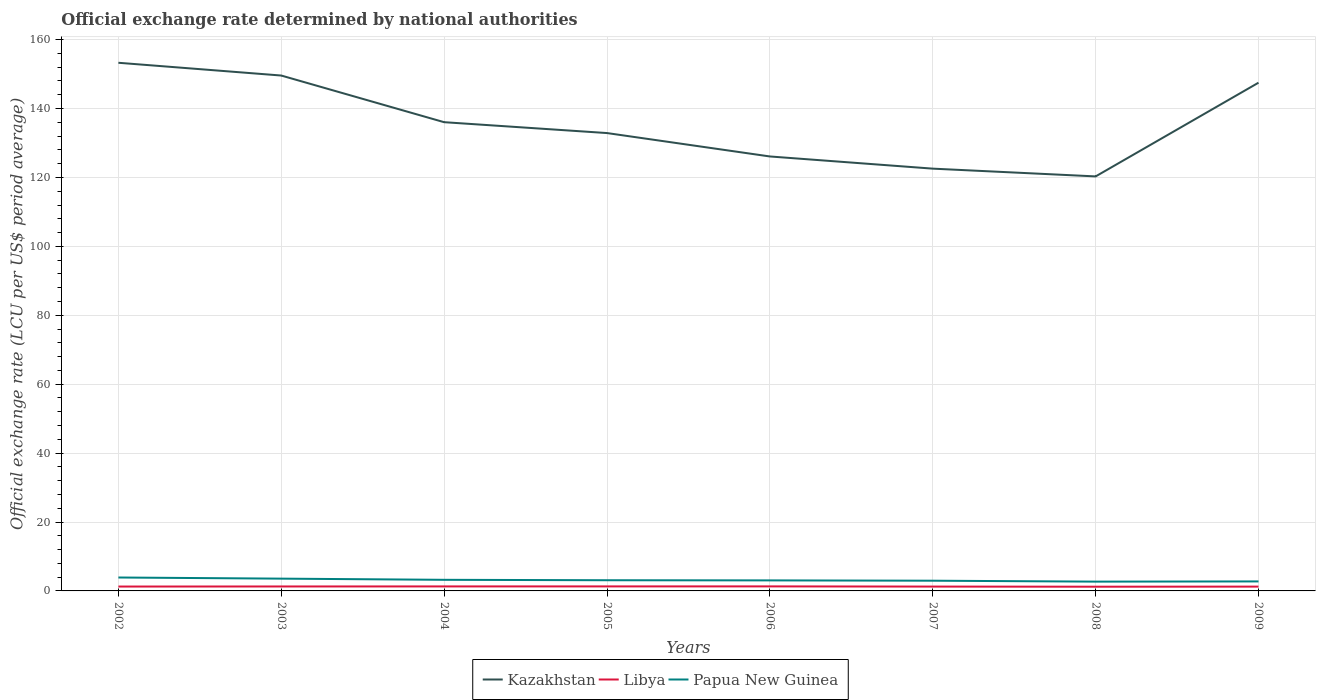How many different coloured lines are there?
Make the answer very short. 3. Is the number of lines equal to the number of legend labels?
Offer a terse response. Yes. Across all years, what is the maximum official exchange rate in Libya?
Provide a succinct answer. 1.22. What is the total official exchange rate in Papua New Guinea in the graph?
Give a very brief answer. 0.86. What is the difference between the highest and the second highest official exchange rate in Libya?
Your answer should be very brief. 0.09. Is the official exchange rate in Papua New Guinea strictly greater than the official exchange rate in Libya over the years?
Keep it short and to the point. No. How many lines are there?
Your answer should be compact. 3. How many years are there in the graph?
Offer a very short reply. 8. Does the graph contain any zero values?
Make the answer very short. No. Does the graph contain grids?
Keep it short and to the point. Yes. Where does the legend appear in the graph?
Your response must be concise. Bottom center. What is the title of the graph?
Make the answer very short. Official exchange rate determined by national authorities. What is the label or title of the Y-axis?
Provide a short and direct response. Official exchange rate (LCU per US$ period average). What is the Official exchange rate (LCU per US$ period average) in Kazakhstan in 2002?
Your response must be concise. 153.28. What is the Official exchange rate (LCU per US$ period average) in Libya in 2002?
Make the answer very short. 1.27. What is the Official exchange rate (LCU per US$ period average) in Papua New Guinea in 2002?
Provide a succinct answer. 3.9. What is the Official exchange rate (LCU per US$ period average) in Kazakhstan in 2003?
Keep it short and to the point. 149.58. What is the Official exchange rate (LCU per US$ period average) of Libya in 2003?
Keep it short and to the point. 1.29. What is the Official exchange rate (LCU per US$ period average) in Papua New Guinea in 2003?
Ensure brevity in your answer.  3.56. What is the Official exchange rate (LCU per US$ period average) of Kazakhstan in 2004?
Your answer should be compact. 136.03. What is the Official exchange rate (LCU per US$ period average) of Libya in 2004?
Ensure brevity in your answer.  1.3. What is the Official exchange rate (LCU per US$ period average) in Papua New Guinea in 2004?
Offer a very short reply. 3.22. What is the Official exchange rate (LCU per US$ period average) in Kazakhstan in 2005?
Keep it short and to the point. 132.88. What is the Official exchange rate (LCU per US$ period average) of Libya in 2005?
Ensure brevity in your answer.  1.31. What is the Official exchange rate (LCU per US$ period average) in Papua New Guinea in 2005?
Keep it short and to the point. 3.1. What is the Official exchange rate (LCU per US$ period average) in Kazakhstan in 2006?
Your answer should be compact. 126.09. What is the Official exchange rate (LCU per US$ period average) of Libya in 2006?
Provide a succinct answer. 1.31. What is the Official exchange rate (LCU per US$ period average) in Papua New Guinea in 2006?
Provide a succinct answer. 3.06. What is the Official exchange rate (LCU per US$ period average) in Kazakhstan in 2007?
Your answer should be compact. 122.55. What is the Official exchange rate (LCU per US$ period average) of Libya in 2007?
Give a very brief answer. 1.26. What is the Official exchange rate (LCU per US$ period average) in Papua New Guinea in 2007?
Make the answer very short. 2.97. What is the Official exchange rate (LCU per US$ period average) in Kazakhstan in 2008?
Your answer should be compact. 120.3. What is the Official exchange rate (LCU per US$ period average) in Libya in 2008?
Ensure brevity in your answer.  1.22. What is the Official exchange rate (LCU per US$ period average) of Papua New Guinea in 2008?
Provide a short and direct response. 2.7. What is the Official exchange rate (LCU per US$ period average) of Kazakhstan in 2009?
Offer a terse response. 147.5. What is the Official exchange rate (LCU per US$ period average) in Libya in 2009?
Offer a very short reply. 1.25. What is the Official exchange rate (LCU per US$ period average) of Papua New Guinea in 2009?
Your answer should be compact. 2.76. Across all years, what is the maximum Official exchange rate (LCU per US$ period average) of Kazakhstan?
Make the answer very short. 153.28. Across all years, what is the maximum Official exchange rate (LCU per US$ period average) of Libya?
Keep it short and to the point. 1.31. Across all years, what is the maximum Official exchange rate (LCU per US$ period average) in Papua New Guinea?
Give a very brief answer. 3.9. Across all years, what is the minimum Official exchange rate (LCU per US$ period average) of Kazakhstan?
Keep it short and to the point. 120.3. Across all years, what is the minimum Official exchange rate (LCU per US$ period average) in Libya?
Your answer should be very brief. 1.22. Across all years, what is the minimum Official exchange rate (LCU per US$ period average) of Papua New Guinea?
Your answer should be compact. 2.7. What is the total Official exchange rate (LCU per US$ period average) of Kazakhstan in the graph?
Give a very brief answer. 1088.21. What is the total Official exchange rate (LCU per US$ period average) in Libya in the graph?
Provide a succinct answer. 10.23. What is the total Official exchange rate (LCU per US$ period average) of Papua New Guinea in the graph?
Keep it short and to the point. 25.26. What is the difference between the Official exchange rate (LCU per US$ period average) in Kazakhstan in 2002 and that in 2003?
Your answer should be very brief. 3.7. What is the difference between the Official exchange rate (LCU per US$ period average) in Libya in 2002 and that in 2003?
Your response must be concise. -0.02. What is the difference between the Official exchange rate (LCU per US$ period average) in Papua New Guinea in 2002 and that in 2003?
Your response must be concise. 0.33. What is the difference between the Official exchange rate (LCU per US$ period average) in Kazakhstan in 2002 and that in 2004?
Ensure brevity in your answer.  17.24. What is the difference between the Official exchange rate (LCU per US$ period average) of Libya in 2002 and that in 2004?
Offer a very short reply. -0.03. What is the difference between the Official exchange rate (LCU per US$ period average) in Papua New Guinea in 2002 and that in 2004?
Provide a short and direct response. 0.67. What is the difference between the Official exchange rate (LCU per US$ period average) in Kazakhstan in 2002 and that in 2005?
Your response must be concise. 20.4. What is the difference between the Official exchange rate (LCU per US$ period average) in Libya in 2002 and that in 2005?
Your response must be concise. -0.04. What is the difference between the Official exchange rate (LCU per US$ period average) of Papua New Guinea in 2002 and that in 2005?
Your answer should be very brief. 0.79. What is the difference between the Official exchange rate (LCU per US$ period average) in Kazakhstan in 2002 and that in 2006?
Your answer should be compact. 27.19. What is the difference between the Official exchange rate (LCU per US$ period average) of Libya in 2002 and that in 2006?
Your response must be concise. -0.04. What is the difference between the Official exchange rate (LCU per US$ period average) in Papua New Guinea in 2002 and that in 2006?
Your answer should be compact. 0.84. What is the difference between the Official exchange rate (LCU per US$ period average) of Kazakhstan in 2002 and that in 2007?
Your response must be concise. 30.73. What is the difference between the Official exchange rate (LCU per US$ period average) in Libya in 2002 and that in 2007?
Ensure brevity in your answer.  0.01. What is the difference between the Official exchange rate (LCU per US$ period average) in Papua New Guinea in 2002 and that in 2007?
Provide a succinct answer. 0.93. What is the difference between the Official exchange rate (LCU per US$ period average) in Kazakhstan in 2002 and that in 2008?
Your response must be concise. 32.98. What is the difference between the Official exchange rate (LCU per US$ period average) in Libya in 2002 and that in 2008?
Give a very brief answer. 0.05. What is the difference between the Official exchange rate (LCU per US$ period average) in Papua New Guinea in 2002 and that in 2008?
Offer a terse response. 1.2. What is the difference between the Official exchange rate (LCU per US$ period average) of Kazakhstan in 2002 and that in 2009?
Provide a short and direct response. 5.78. What is the difference between the Official exchange rate (LCU per US$ period average) in Libya in 2002 and that in 2009?
Offer a terse response. 0.02. What is the difference between the Official exchange rate (LCU per US$ period average) of Papua New Guinea in 2002 and that in 2009?
Ensure brevity in your answer.  1.14. What is the difference between the Official exchange rate (LCU per US$ period average) in Kazakhstan in 2003 and that in 2004?
Provide a short and direct response. 13.54. What is the difference between the Official exchange rate (LCU per US$ period average) of Libya in 2003 and that in 2004?
Give a very brief answer. -0.01. What is the difference between the Official exchange rate (LCU per US$ period average) of Papua New Guinea in 2003 and that in 2004?
Offer a very short reply. 0.34. What is the difference between the Official exchange rate (LCU per US$ period average) in Kazakhstan in 2003 and that in 2005?
Make the answer very short. 16.7. What is the difference between the Official exchange rate (LCU per US$ period average) in Libya in 2003 and that in 2005?
Provide a succinct answer. -0.02. What is the difference between the Official exchange rate (LCU per US$ period average) of Papua New Guinea in 2003 and that in 2005?
Provide a succinct answer. 0.46. What is the difference between the Official exchange rate (LCU per US$ period average) of Kazakhstan in 2003 and that in 2006?
Ensure brevity in your answer.  23.49. What is the difference between the Official exchange rate (LCU per US$ period average) in Libya in 2003 and that in 2006?
Offer a very short reply. -0.02. What is the difference between the Official exchange rate (LCU per US$ period average) of Papua New Guinea in 2003 and that in 2006?
Your response must be concise. 0.51. What is the difference between the Official exchange rate (LCU per US$ period average) in Kazakhstan in 2003 and that in 2007?
Your response must be concise. 27.02. What is the difference between the Official exchange rate (LCU per US$ period average) of Libya in 2003 and that in 2007?
Give a very brief answer. 0.03. What is the difference between the Official exchange rate (LCU per US$ period average) in Papua New Guinea in 2003 and that in 2007?
Provide a short and direct response. 0.6. What is the difference between the Official exchange rate (LCU per US$ period average) in Kazakhstan in 2003 and that in 2008?
Offer a terse response. 29.28. What is the difference between the Official exchange rate (LCU per US$ period average) of Libya in 2003 and that in 2008?
Offer a very short reply. 0.07. What is the difference between the Official exchange rate (LCU per US$ period average) of Papua New Guinea in 2003 and that in 2008?
Ensure brevity in your answer.  0.86. What is the difference between the Official exchange rate (LCU per US$ period average) in Kazakhstan in 2003 and that in 2009?
Make the answer very short. 2.08. What is the difference between the Official exchange rate (LCU per US$ period average) of Libya in 2003 and that in 2009?
Provide a short and direct response. 0.04. What is the difference between the Official exchange rate (LCU per US$ period average) in Papua New Guinea in 2003 and that in 2009?
Ensure brevity in your answer.  0.81. What is the difference between the Official exchange rate (LCU per US$ period average) in Kazakhstan in 2004 and that in 2005?
Provide a succinct answer. 3.15. What is the difference between the Official exchange rate (LCU per US$ period average) of Libya in 2004 and that in 2005?
Offer a very short reply. -0. What is the difference between the Official exchange rate (LCU per US$ period average) in Papua New Guinea in 2004 and that in 2005?
Offer a terse response. 0.12. What is the difference between the Official exchange rate (LCU per US$ period average) of Kazakhstan in 2004 and that in 2006?
Your answer should be very brief. 9.95. What is the difference between the Official exchange rate (LCU per US$ period average) in Libya in 2004 and that in 2006?
Give a very brief answer. -0.01. What is the difference between the Official exchange rate (LCU per US$ period average) in Papua New Guinea in 2004 and that in 2006?
Make the answer very short. 0.17. What is the difference between the Official exchange rate (LCU per US$ period average) of Kazakhstan in 2004 and that in 2007?
Your response must be concise. 13.48. What is the difference between the Official exchange rate (LCU per US$ period average) in Libya in 2004 and that in 2007?
Offer a very short reply. 0.04. What is the difference between the Official exchange rate (LCU per US$ period average) of Papua New Guinea in 2004 and that in 2007?
Provide a succinct answer. 0.26. What is the difference between the Official exchange rate (LCU per US$ period average) of Kazakhstan in 2004 and that in 2008?
Make the answer very short. 15.74. What is the difference between the Official exchange rate (LCU per US$ period average) in Libya in 2004 and that in 2008?
Offer a terse response. 0.08. What is the difference between the Official exchange rate (LCU per US$ period average) in Papua New Guinea in 2004 and that in 2008?
Keep it short and to the point. 0.52. What is the difference between the Official exchange rate (LCU per US$ period average) of Kazakhstan in 2004 and that in 2009?
Offer a terse response. -11.46. What is the difference between the Official exchange rate (LCU per US$ period average) of Libya in 2004 and that in 2009?
Ensure brevity in your answer.  0.05. What is the difference between the Official exchange rate (LCU per US$ period average) in Papua New Guinea in 2004 and that in 2009?
Provide a succinct answer. 0.47. What is the difference between the Official exchange rate (LCU per US$ period average) in Kazakhstan in 2005 and that in 2006?
Your response must be concise. 6.79. What is the difference between the Official exchange rate (LCU per US$ period average) in Libya in 2005 and that in 2006?
Make the answer very short. -0.01. What is the difference between the Official exchange rate (LCU per US$ period average) of Papua New Guinea in 2005 and that in 2006?
Offer a very short reply. 0.05. What is the difference between the Official exchange rate (LCU per US$ period average) in Kazakhstan in 2005 and that in 2007?
Offer a very short reply. 10.33. What is the difference between the Official exchange rate (LCU per US$ period average) in Libya in 2005 and that in 2007?
Your answer should be very brief. 0.05. What is the difference between the Official exchange rate (LCU per US$ period average) in Papua New Guinea in 2005 and that in 2007?
Your answer should be very brief. 0.14. What is the difference between the Official exchange rate (LCU per US$ period average) of Kazakhstan in 2005 and that in 2008?
Provide a succinct answer. 12.58. What is the difference between the Official exchange rate (LCU per US$ period average) in Libya in 2005 and that in 2008?
Give a very brief answer. 0.08. What is the difference between the Official exchange rate (LCU per US$ period average) of Papua New Guinea in 2005 and that in 2008?
Your response must be concise. 0.4. What is the difference between the Official exchange rate (LCU per US$ period average) in Kazakhstan in 2005 and that in 2009?
Offer a very short reply. -14.62. What is the difference between the Official exchange rate (LCU per US$ period average) in Libya in 2005 and that in 2009?
Your answer should be compact. 0.05. What is the difference between the Official exchange rate (LCU per US$ period average) in Papua New Guinea in 2005 and that in 2009?
Provide a short and direct response. 0.35. What is the difference between the Official exchange rate (LCU per US$ period average) in Kazakhstan in 2006 and that in 2007?
Provide a short and direct response. 3.54. What is the difference between the Official exchange rate (LCU per US$ period average) in Libya in 2006 and that in 2007?
Ensure brevity in your answer.  0.05. What is the difference between the Official exchange rate (LCU per US$ period average) in Papua New Guinea in 2006 and that in 2007?
Keep it short and to the point. 0.09. What is the difference between the Official exchange rate (LCU per US$ period average) of Kazakhstan in 2006 and that in 2008?
Your answer should be compact. 5.79. What is the difference between the Official exchange rate (LCU per US$ period average) in Libya in 2006 and that in 2008?
Offer a very short reply. 0.09. What is the difference between the Official exchange rate (LCU per US$ period average) of Papua New Guinea in 2006 and that in 2008?
Your response must be concise. 0.36. What is the difference between the Official exchange rate (LCU per US$ period average) of Kazakhstan in 2006 and that in 2009?
Offer a very short reply. -21.41. What is the difference between the Official exchange rate (LCU per US$ period average) of Libya in 2006 and that in 2009?
Your answer should be compact. 0.06. What is the difference between the Official exchange rate (LCU per US$ period average) in Papua New Guinea in 2006 and that in 2009?
Offer a terse response. 0.3. What is the difference between the Official exchange rate (LCU per US$ period average) in Kazakhstan in 2007 and that in 2008?
Your response must be concise. 2.25. What is the difference between the Official exchange rate (LCU per US$ period average) of Libya in 2007 and that in 2008?
Offer a terse response. 0.04. What is the difference between the Official exchange rate (LCU per US$ period average) of Papua New Guinea in 2007 and that in 2008?
Your response must be concise. 0.27. What is the difference between the Official exchange rate (LCU per US$ period average) of Kazakhstan in 2007 and that in 2009?
Your answer should be very brief. -24.94. What is the difference between the Official exchange rate (LCU per US$ period average) of Libya in 2007 and that in 2009?
Make the answer very short. 0.01. What is the difference between the Official exchange rate (LCU per US$ period average) in Papua New Guinea in 2007 and that in 2009?
Your answer should be very brief. 0.21. What is the difference between the Official exchange rate (LCU per US$ period average) of Kazakhstan in 2008 and that in 2009?
Ensure brevity in your answer.  -27.2. What is the difference between the Official exchange rate (LCU per US$ period average) in Libya in 2008 and that in 2009?
Offer a very short reply. -0.03. What is the difference between the Official exchange rate (LCU per US$ period average) of Papua New Guinea in 2008 and that in 2009?
Your answer should be very brief. -0.06. What is the difference between the Official exchange rate (LCU per US$ period average) of Kazakhstan in 2002 and the Official exchange rate (LCU per US$ period average) of Libya in 2003?
Make the answer very short. 151.99. What is the difference between the Official exchange rate (LCU per US$ period average) in Kazakhstan in 2002 and the Official exchange rate (LCU per US$ period average) in Papua New Guinea in 2003?
Your response must be concise. 149.72. What is the difference between the Official exchange rate (LCU per US$ period average) of Libya in 2002 and the Official exchange rate (LCU per US$ period average) of Papua New Guinea in 2003?
Offer a very short reply. -2.29. What is the difference between the Official exchange rate (LCU per US$ period average) in Kazakhstan in 2002 and the Official exchange rate (LCU per US$ period average) in Libya in 2004?
Make the answer very short. 151.97. What is the difference between the Official exchange rate (LCU per US$ period average) of Kazakhstan in 2002 and the Official exchange rate (LCU per US$ period average) of Papua New Guinea in 2004?
Your response must be concise. 150.06. What is the difference between the Official exchange rate (LCU per US$ period average) in Libya in 2002 and the Official exchange rate (LCU per US$ period average) in Papua New Guinea in 2004?
Offer a very short reply. -1.95. What is the difference between the Official exchange rate (LCU per US$ period average) in Kazakhstan in 2002 and the Official exchange rate (LCU per US$ period average) in Libya in 2005?
Offer a very short reply. 151.97. What is the difference between the Official exchange rate (LCU per US$ period average) in Kazakhstan in 2002 and the Official exchange rate (LCU per US$ period average) in Papua New Guinea in 2005?
Your answer should be compact. 150.18. What is the difference between the Official exchange rate (LCU per US$ period average) of Libya in 2002 and the Official exchange rate (LCU per US$ period average) of Papua New Guinea in 2005?
Provide a short and direct response. -1.83. What is the difference between the Official exchange rate (LCU per US$ period average) in Kazakhstan in 2002 and the Official exchange rate (LCU per US$ period average) in Libya in 2006?
Ensure brevity in your answer.  151.97. What is the difference between the Official exchange rate (LCU per US$ period average) in Kazakhstan in 2002 and the Official exchange rate (LCU per US$ period average) in Papua New Guinea in 2006?
Make the answer very short. 150.22. What is the difference between the Official exchange rate (LCU per US$ period average) of Libya in 2002 and the Official exchange rate (LCU per US$ period average) of Papua New Guinea in 2006?
Your response must be concise. -1.79. What is the difference between the Official exchange rate (LCU per US$ period average) of Kazakhstan in 2002 and the Official exchange rate (LCU per US$ period average) of Libya in 2007?
Make the answer very short. 152.02. What is the difference between the Official exchange rate (LCU per US$ period average) of Kazakhstan in 2002 and the Official exchange rate (LCU per US$ period average) of Papua New Guinea in 2007?
Give a very brief answer. 150.31. What is the difference between the Official exchange rate (LCU per US$ period average) in Libya in 2002 and the Official exchange rate (LCU per US$ period average) in Papua New Guinea in 2007?
Offer a very short reply. -1.69. What is the difference between the Official exchange rate (LCU per US$ period average) in Kazakhstan in 2002 and the Official exchange rate (LCU per US$ period average) in Libya in 2008?
Give a very brief answer. 152.06. What is the difference between the Official exchange rate (LCU per US$ period average) in Kazakhstan in 2002 and the Official exchange rate (LCU per US$ period average) in Papua New Guinea in 2008?
Give a very brief answer. 150.58. What is the difference between the Official exchange rate (LCU per US$ period average) in Libya in 2002 and the Official exchange rate (LCU per US$ period average) in Papua New Guinea in 2008?
Your response must be concise. -1.43. What is the difference between the Official exchange rate (LCU per US$ period average) in Kazakhstan in 2002 and the Official exchange rate (LCU per US$ period average) in Libya in 2009?
Keep it short and to the point. 152.03. What is the difference between the Official exchange rate (LCU per US$ period average) of Kazakhstan in 2002 and the Official exchange rate (LCU per US$ period average) of Papua New Guinea in 2009?
Provide a short and direct response. 150.52. What is the difference between the Official exchange rate (LCU per US$ period average) of Libya in 2002 and the Official exchange rate (LCU per US$ period average) of Papua New Guinea in 2009?
Offer a terse response. -1.48. What is the difference between the Official exchange rate (LCU per US$ period average) of Kazakhstan in 2003 and the Official exchange rate (LCU per US$ period average) of Libya in 2004?
Offer a very short reply. 148.27. What is the difference between the Official exchange rate (LCU per US$ period average) in Kazakhstan in 2003 and the Official exchange rate (LCU per US$ period average) in Papua New Guinea in 2004?
Make the answer very short. 146.35. What is the difference between the Official exchange rate (LCU per US$ period average) in Libya in 2003 and the Official exchange rate (LCU per US$ period average) in Papua New Guinea in 2004?
Make the answer very short. -1.93. What is the difference between the Official exchange rate (LCU per US$ period average) in Kazakhstan in 2003 and the Official exchange rate (LCU per US$ period average) in Libya in 2005?
Offer a terse response. 148.27. What is the difference between the Official exchange rate (LCU per US$ period average) in Kazakhstan in 2003 and the Official exchange rate (LCU per US$ period average) in Papua New Guinea in 2005?
Offer a terse response. 146.47. What is the difference between the Official exchange rate (LCU per US$ period average) of Libya in 2003 and the Official exchange rate (LCU per US$ period average) of Papua New Guinea in 2005?
Your answer should be very brief. -1.81. What is the difference between the Official exchange rate (LCU per US$ period average) of Kazakhstan in 2003 and the Official exchange rate (LCU per US$ period average) of Libya in 2006?
Your answer should be very brief. 148.26. What is the difference between the Official exchange rate (LCU per US$ period average) of Kazakhstan in 2003 and the Official exchange rate (LCU per US$ period average) of Papua New Guinea in 2006?
Ensure brevity in your answer.  146.52. What is the difference between the Official exchange rate (LCU per US$ period average) of Libya in 2003 and the Official exchange rate (LCU per US$ period average) of Papua New Guinea in 2006?
Keep it short and to the point. -1.76. What is the difference between the Official exchange rate (LCU per US$ period average) of Kazakhstan in 2003 and the Official exchange rate (LCU per US$ period average) of Libya in 2007?
Provide a short and direct response. 148.31. What is the difference between the Official exchange rate (LCU per US$ period average) of Kazakhstan in 2003 and the Official exchange rate (LCU per US$ period average) of Papua New Guinea in 2007?
Provide a succinct answer. 146.61. What is the difference between the Official exchange rate (LCU per US$ period average) of Libya in 2003 and the Official exchange rate (LCU per US$ period average) of Papua New Guinea in 2007?
Keep it short and to the point. -1.67. What is the difference between the Official exchange rate (LCU per US$ period average) in Kazakhstan in 2003 and the Official exchange rate (LCU per US$ period average) in Libya in 2008?
Your response must be concise. 148.35. What is the difference between the Official exchange rate (LCU per US$ period average) of Kazakhstan in 2003 and the Official exchange rate (LCU per US$ period average) of Papua New Guinea in 2008?
Offer a very short reply. 146.88. What is the difference between the Official exchange rate (LCU per US$ period average) in Libya in 2003 and the Official exchange rate (LCU per US$ period average) in Papua New Guinea in 2008?
Make the answer very short. -1.41. What is the difference between the Official exchange rate (LCU per US$ period average) in Kazakhstan in 2003 and the Official exchange rate (LCU per US$ period average) in Libya in 2009?
Provide a succinct answer. 148.32. What is the difference between the Official exchange rate (LCU per US$ period average) of Kazakhstan in 2003 and the Official exchange rate (LCU per US$ period average) of Papua New Guinea in 2009?
Provide a short and direct response. 146.82. What is the difference between the Official exchange rate (LCU per US$ period average) in Libya in 2003 and the Official exchange rate (LCU per US$ period average) in Papua New Guinea in 2009?
Keep it short and to the point. -1.46. What is the difference between the Official exchange rate (LCU per US$ period average) in Kazakhstan in 2004 and the Official exchange rate (LCU per US$ period average) in Libya in 2005?
Provide a short and direct response. 134.73. What is the difference between the Official exchange rate (LCU per US$ period average) of Kazakhstan in 2004 and the Official exchange rate (LCU per US$ period average) of Papua New Guinea in 2005?
Give a very brief answer. 132.93. What is the difference between the Official exchange rate (LCU per US$ period average) in Libya in 2004 and the Official exchange rate (LCU per US$ period average) in Papua New Guinea in 2005?
Your answer should be very brief. -1.8. What is the difference between the Official exchange rate (LCU per US$ period average) of Kazakhstan in 2004 and the Official exchange rate (LCU per US$ period average) of Libya in 2006?
Your answer should be compact. 134.72. What is the difference between the Official exchange rate (LCU per US$ period average) in Kazakhstan in 2004 and the Official exchange rate (LCU per US$ period average) in Papua New Guinea in 2006?
Give a very brief answer. 132.98. What is the difference between the Official exchange rate (LCU per US$ period average) of Libya in 2004 and the Official exchange rate (LCU per US$ period average) of Papua New Guinea in 2006?
Provide a succinct answer. -1.75. What is the difference between the Official exchange rate (LCU per US$ period average) of Kazakhstan in 2004 and the Official exchange rate (LCU per US$ period average) of Libya in 2007?
Offer a very short reply. 134.77. What is the difference between the Official exchange rate (LCU per US$ period average) in Kazakhstan in 2004 and the Official exchange rate (LCU per US$ period average) in Papua New Guinea in 2007?
Offer a very short reply. 133.07. What is the difference between the Official exchange rate (LCU per US$ period average) of Libya in 2004 and the Official exchange rate (LCU per US$ period average) of Papua New Guinea in 2007?
Provide a short and direct response. -1.66. What is the difference between the Official exchange rate (LCU per US$ period average) of Kazakhstan in 2004 and the Official exchange rate (LCU per US$ period average) of Libya in 2008?
Offer a terse response. 134.81. What is the difference between the Official exchange rate (LCU per US$ period average) of Kazakhstan in 2004 and the Official exchange rate (LCU per US$ period average) of Papua New Guinea in 2008?
Your answer should be compact. 133.33. What is the difference between the Official exchange rate (LCU per US$ period average) in Libya in 2004 and the Official exchange rate (LCU per US$ period average) in Papua New Guinea in 2008?
Your response must be concise. -1.4. What is the difference between the Official exchange rate (LCU per US$ period average) of Kazakhstan in 2004 and the Official exchange rate (LCU per US$ period average) of Libya in 2009?
Offer a very short reply. 134.78. What is the difference between the Official exchange rate (LCU per US$ period average) in Kazakhstan in 2004 and the Official exchange rate (LCU per US$ period average) in Papua New Guinea in 2009?
Make the answer very short. 133.28. What is the difference between the Official exchange rate (LCU per US$ period average) in Libya in 2004 and the Official exchange rate (LCU per US$ period average) in Papua New Guinea in 2009?
Offer a very short reply. -1.45. What is the difference between the Official exchange rate (LCU per US$ period average) in Kazakhstan in 2005 and the Official exchange rate (LCU per US$ period average) in Libya in 2006?
Your answer should be very brief. 131.57. What is the difference between the Official exchange rate (LCU per US$ period average) in Kazakhstan in 2005 and the Official exchange rate (LCU per US$ period average) in Papua New Guinea in 2006?
Your answer should be compact. 129.82. What is the difference between the Official exchange rate (LCU per US$ period average) in Libya in 2005 and the Official exchange rate (LCU per US$ period average) in Papua New Guinea in 2006?
Your answer should be compact. -1.75. What is the difference between the Official exchange rate (LCU per US$ period average) of Kazakhstan in 2005 and the Official exchange rate (LCU per US$ period average) of Libya in 2007?
Make the answer very short. 131.62. What is the difference between the Official exchange rate (LCU per US$ period average) in Kazakhstan in 2005 and the Official exchange rate (LCU per US$ period average) in Papua New Guinea in 2007?
Offer a very short reply. 129.91. What is the difference between the Official exchange rate (LCU per US$ period average) of Libya in 2005 and the Official exchange rate (LCU per US$ period average) of Papua New Guinea in 2007?
Your response must be concise. -1.66. What is the difference between the Official exchange rate (LCU per US$ period average) in Kazakhstan in 2005 and the Official exchange rate (LCU per US$ period average) in Libya in 2008?
Give a very brief answer. 131.66. What is the difference between the Official exchange rate (LCU per US$ period average) in Kazakhstan in 2005 and the Official exchange rate (LCU per US$ period average) in Papua New Guinea in 2008?
Keep it short and to the point. 130.18. What is the difference between the Official exchange rate (LCU per US$ period average) in Libya in 2005 and the Official exchange rate (LCU per US$ period average) in Papua New Guinea in 2008?
Give a very brief answer. -1.39. What is the difference between the Official exchange rate (LCU per US$ period average) in Kazakhstan in 2005 and the Official exchange rate (LCU per US$ period average) in Libya in 2009?
Provide a succinct answer. 131.63. What is the difference between the Official exchange rate (LCU per US$ period average) of Kazakhstan in 2005 and the Official exchange rate (LCU per US$ period average) of Papua New Guinea in 2009?
Make the answer very short. 130.12. What is the difference between the Official exchange rate (LCU per US$ period average) of Libya in 2005 and the Official exchange rate (LCU per US$ period average) of Papua New Guinea in 2009?
Your response must be concise. -1.45. What is the difference between the Official exchange rate (LCU per US$ period average) in Kazakhstan in 2006 and the Official exchange rate (LCU per US$ period average) in Libya in 2007?
Offer a very short reply. 124.83. What is the difference between the Official exchange rate (LCU per US$ period average) in Kazakhstan in 2006 and the Official exchange rate (LCU per US$ period average) in Papua New Guinea in 2007?
Your answer should be very brief. 123.12. What is the difference between the Official exchange rate (LCU per US$ period average) of Libya in 2006 and the Official exchange rate (LCU per US$ period average) of Papua New Guinea in 2007?
Provide a short and direct response. -1.65. What is the difference between the Official exchange rate (LCU per US$ period average) of Kazakhstan in 2006 and the Official exchange rate (LCU per US$ period average) of Libya in 2008?
Your answer should be very brief. 124.87. What is the difference between the Official exchange rate (LCU per US$ period average) in Kazakhstan in 2006 and the Official exchange rate (LCU per US$ period average) in Papua New Guinea in 2008?
Make the answer very short. 123.39. What is the difference between the Official exchange rate (LCU per US$ period average) in Libya in 2006 and the Official exchange rate (LCU per US$ period average) in Papua New Guinea in 2008?
Provide a succinct answer. -1.39. What is the difference between the Official exchange rate (LCU per US$ period average) of Kazakhstan in 2006 and the Official exchange rate (LCU per US$ period average) of Libya in 2009?
Offer a very short reply. 124.84. What is the difference between the Official exchange rate (LCU per US$ period average) of Kazakhstan in 2006 and the Official exchange rate (LCU per US$ period average) of Papua New Guinea in 2009?
Provide a succinct answer. 123.33. What is the difference between the Official exchange rate (LCU per US$ period average) in Libya in 2006 and the Official exchange rate (LCU per US$ period average) in Papua New Guinea in 2009?
Keep it short and to the point. -1.44. What is the difference between the Official exchange rate (LCU per US$ period average) of Kazakhstan in 2007 and the Official exchange rate (LCU per US$ period average) of Libya in 2008?
Ensure brevity in your answer.  121.33. What is the difference between the Official exchange rate (LCU per US$ period average) of Kazakhstan in 2007 and the Official exchange rate (LCU per US$ period average) of Papua New Guinea in 2008?
Provide a succinct answer. 119.85. What is the difference between the Official exchange rate (LCU per US$ period average) of Libya in 2007 and the Official exchange rate (LCU per US$ period average) of Papua New Guinea in 2008?
Offer a very short reply. -1.44. What is the difference between the Official exchange rate (LCU per US$ period average) of Kazakhstan in 2007 and the Official exchange rate (LCU per US$ period average) of Libya in 2009?
Your answer should be compact. 121.3. What is the difference between the Official exchange rate (LCU per US$ period average) of Kazakhstan in 2007 and the Official exchange rate (LCU per US$ period average) of Papua New Guinea in 2009?
Offer a very short reply. 119.8. What is the difference between the Official exchange rate (LCU per US$ period average) in Libya in 2007 and the Official exchange rate (LCU per US$ period average) in Papua New Guinea in 2009?
Make the answer very short. -1.49. What is the difference between the Official exchange rate (LCU per US$ period average) in Kazakhstan in 2008 and the Official exchange rate (LCU per US$ period average) in Libya in 2009?
Keep it short and to the point. 119.05. What is the difference between the Official exchange rate (LCU per US$ period average) of Kazakhstan in 2008 and the Official exchange rate (LCU per US$ period average) of Papua New Guinea in 2009?
Your response must be concise. 117.54. What is the difference between the Official exchange rate (LCU per US$ period average) in Libya in 2008 and the Official exchange rate (LCU per US$ period average) in Papua New Guinea in 2009?
Your answer should be compact. -1.53. What is the average Official exchange rate (LCU per US$ period average) of Kazakhstan per year?
Your response must be concise. 136.03. What is the average Official exchange rate (LCU per US$ period average) in Libya per year?
Give a very brief answer. 1.28. What is the average Official exchange rate (LCU per US$ period average) of Papua New Guinea per year?
Your answer should be very brief. 3.16. In the year 2002, what is the difference between the Official exchange rate (LCU per US$ period average) in Kazakhstan and Official exchange rate (LCU per US$ period average) in Libya?
Provide a succinct answer. 152.01. In the year 2002, what is the difference between the Official exchange rate (LCU per US$ period average) of Kazakhstan and Official exchange rate (LCU per US$ period average) of Papua New Guinea?
Give a very brief answer. 149.38. In the year 2002, what is the difference between the Official exchange rate (LCU per US$ period average) in Libya and Official exchange rate (LCU per US$ period average) in Papua New Guinea?
Your answer should be very brief. -2.62. In the year 2003, what is the difference between the Official exchange rate (LCU per US$ period average) in Kazakhstan and Official exchange rate (LCU per US$ period average) in Libya?
Offer a terse response. 148.28. In the year 2003, what is the difference between the Official exchange rate (LCU per US$ period average) in Kazakhstan and Official exchange rate (LCU per US$ period average) in Papua New Guinea?
Provide a short and direct response. 146.01. In the year 2003, what is the difference between the Official exchange rate (LCU per US$ period average) in Libya and Official exchange rate (LCU per US$ period average) in Papua New Guinea?
Provide a short and direct response. -2.27. In the year 2004, what is the difference between the Official exchange rate (LCU per US$ period average) in Kazakhstan and Official exchange rate (LCU per US$ period average) in Libya?
Make the answer very short. 134.73. In the year 2004, what is the difference between the Official exchange rate (LCU per US$ period average) in Kazakhstan and Official exchange rate (LCU per US$ period average) in Papua New Guinea?
Your answer should be compact. 132.81. In the year 2004, what is the difference between the Official exchange rate (LCU per US$ period average) in Libya and Official exchange rate (LCU per US$ period average) in Papua New Guinea?
Ensure brevity in your answer.  -1.92. In the year 2005, what is the difference between the Official exchange rate (LCU per US$ period average) in Kazakhstan and Official exchange rate (LCU per US$ period average) in Libya?
Your answer should be very brief. 131.57. In the year 2005, what is the difference between the Official exchange rate (LCU per US$ period average) in Kazakhstan and Official exchange rate (LCU per US$ period average) in Papua New Guinea?
Give a very brief answer. 129.78. In the year 2005, what is the difference between the Official exchange rate (LCU per US$ period average) of Libya and Official exchange rate (LCU per US$ period average) of Papua New Guinea?
Your response must be concise. -1.79. In the year 2006, what is the difference between the Official exchange rate (LCU per US$ period average) in Kazakhstan and Official exchange rate (LCU per US$ period average) in Libya?
Give a very brief answer. 124.78. In the year 2006, what is the difference between the Official exchange rate (LCU per US$ period average) of Kazakhstan and Official exchange rate (LCU per US$ period average) of Papua New Guinea?
Offer a very short reply. 123.03. In the year 2006, what is the difference between the Official exchange rate (LCU per US$ period average) in Libya and Official exchange rate (LCU per US$ period average) in Papua New Guinea?
Your answer should be compact. -1.74. In the year 2007, what is the difference between the Official exchange rate (LCU per US$ period average) of Kazakhstan and Official exchange rate (LCU per US$ period average) of Libya?
Your answer should be very brief. 121.29. In the year 2007, what is the difference between the Official exchange rate (LCU per US$ period average) in Kazakhstan and Official exchange rate (LCU per US$ period average) in Papua New Guinea?
Offer a very short reply. 119.59. In the year 2007, what is the difference between the Official exchange rate (LCU per US$ period average) in Libya and Official exchange rate (LCU per US$ period average) in Papua New Guinea?
Ensure brevity in your answer.  -1.7. In the year 2008, what is the difference between the Official exchange rate (LCU per US$ period average) of Kazakhstan and Official exchange rate (LCU per US$ period average) of Libya?
Give a very brief answer. 119.08. In the year 2008, what is the difference between the Official exchange rate (LCU per US$ period average) of Kazakhstan and Official exchange rate (LCU per US$ period average) of Papua New Guinea?
Your answer should be very brief. 117.6. In the year 2008, what is the difference between the Official exchange rate (LCU per US$ period average) of Libya and Official exchange rate (LCU per US$ period average) of Papua New Guinea?
Provide a short and direct response. -1.48. In the year 2009, what is the difference between the Official exchange rate (LCU per US$ period average) of Kazakhstan and Official exchange rate (LCU per US$ period average) of Libya?
Your answer should be compact. 146.24. In the year 2009, what is the difference between the Official exchange rate (LCU per US$ period average) of Kazakhstan and Official exchange rate (LCU per US$ period average) of Papua New Guinea?
Give a very brief answer. 144.74. In the year 2009, what is the difference between the Official exchange rate (LCU per US$ period average) of Libya and Official exchange rate (LCU per US$ period average) of Papua New Guinea?
Provide a short and direct response. -1.5. What is the ratio of the Official exchange rate (LCU per US$ period average) in Kazakhstan in 2002 to that in 2003?
Make the answer very short. 1.02. What is the ratio of the Official exchange rate (LCU per US$ period average) in Libya in 2002 to that in 2003?
Provide a succinct answer. 0.98. What is the ratio of the Official exchange rate (LCU per US$ period average) of Papua New Guinea in 2002 to that in 2003?
Your answer should be very brief. 1.09. What is the ratio of the Official exchange rate (LCU per US$ period average) of Kazakhstan in 2002 to that in 2004?
Provide a succinct answer. 1.13. What is the ratio of the Official exchange rate (LCU per US$ period average) in Libya in 2002 to that in 2004?
Make the answer very short. 0.97. What is the ratio of the Official exchange rate (LCU per US$ period average) of Papua New Guinea in 2002 to that in 2004?
Your answer should be compact. 1.21. What is the ratio of the Official exchange rate (LCU per US$ period average) in Kazakhstan in 2002 to that in 2005?
Give a very brief answer. 1.15. What is the ratio of the Official exchange rate (LCU per US$ period average) in Libya in 2002 to that in 2005?
Your response must be concise. 0.97. What is the ratio of the Official exchange rate (LCU per US$ period average) in Papua New Guinea in 2002 to that in 2005?
Your response must be concise. 1.26. What is the ratio of the Official exchange rate (LCU per US$ period average) in Kazakhstan in 2002 to that in 2006?
Give a very brief answer. 1.22. What is the ratio of the Official exchange rate (LCU per US$ period average) in Libya in 2002 to that in 2006?
Give a very brief answer. 0.97. What is the ratio of the Official exchange rate (LCU per US$ period average) of Papua New Guinea in 2002 to that in 2006?
Your answer should be very brief. 1.27. What is the ratio of the Official exchange rate (LCU per US$ period average) in Kazakhstan in 2002 to that in 2007?
Make the answer very short. 1.25. What is the ratio of the Official exchange rate (LCU per US$ period average) of Libya in 2002 to that in 2007?
Your answer should be very brief. 1.01. What is the ratio of the Official exchange rate (LCU per US$ period average) in Papua New Guinea in 2002 to that in 2007?
Keep it short and to the point. 1.31. What is the ratio of the Official exchange rate (LCU per US$ period average) of Kazakhstan in 2002 to that in 2008?
Your answer should be compact. 1.27. What is the ratio of the Official exchange rate (LCU per US$ period average) of Libya in 2002 to that in 2008?
Make the answer very short. 1.04. What is the ratio of the Official exchange rate (LCU per US$ period average) in Papua New Guinea in 2002 to that in 2008?
Offer a very short reply. 1.44. What is the ratio of the Official exchange rate (LCU per US$ period average) in Kazakhstan in 2002 to that in 2009?
Keep it short and to the point. 1.04. What is the ratio of the Official exchange rate (LCU per US$ period average) of Libya in 2002 to that in 2009?
Make the answer very short. 1.01. What is the ratio of the Official exchange rate (LCU per US$ period average) of Papua New Guinea in 2002 to that in 2009?
Your answer should be very brief. 1.41. What is the ratio of the Official exchange rate (LCU per US$ period average) of Kazakhstan in 2003 to that in 2004?
Provide a short and direct response. 1.1. What is the ratio of the Official exchange rate (LCU per US$ period average) of Papua New Guinea in 2003 to that in 2004?
Keep it short and to the point. 1.11. What is the ratio of the Official exchange rate (LCU per US$ period average) in Kazakhstan in 2003 to that in 2005?
Offer a terse response. 1.13. What is the ratio of the Official exchange rate (LCU per US$ period average) of Libya in 2003 to that in 2005?
Make the answer very short. 0.99. What is the ratio of the Official exchange rate (LCU per US$ period average) in Papua New Guinea in 2003 to that in 2005?
Your response must be concise. 1.15. What is the ratio of the Official exchange rate (LCU per US$ period average) of Kazakhstan in 2003 to that in 2006?
Your response must be concise. 1.19. What is the ratio of the Official exchange rate (LCU per US$ period average) of Libya in 2003 to that in 2006?
Your answer should be very brief. 0.98. What is the ratio of the Official exchange rate (LCU per US$ period average) in Papua New Guinea in 2003 to that in 2006?
Offer a very short reply. 1.17. What is the ratio of the Official exchange rate (LCU per US$ period average) in Kazakhstan in 2003 to that in 2007?
Your answer should be compact. 1.22. What is the ratio of the Official exchange rate (LCU per US$ period average) of Libya in 2003 to that in 2007?
Provide a short and direct response. 1.02. What is the ratio of the Official exchange rate (LCU per US$ period average) in Papua New Guinea in 2003 to that in 2007?
Give a very brief answer. 1.2. What is the ratio of the Official exchange rate (LCU per US$ period average) of Kazakhstan in 2003 to that in 2008?
Provide a succinct answer. 1.24. What is the ratio of the Official exchange rate (LCU per US$ period average) of Libya in 2003 to that in 2008?
Your answer should be compact. 1.06. What is the ratio of the Official exchange rate (LCU per US$ period average) of Papua New Guinea in 2003 to that in 2008?
Offer a very short reply. 1.32. What is the ratio of the Official exchange rate (LCU per US$ period average) of Kazakhstan in 2003 to that in 2009?
Offer a terse response. 1.01. What is the ratio of the Official exchange rate (LCU per US$ period average) of Libya in 2003 to that in 2009?
Your answer should be very brief. 1.03. What is the ratio of the Official exchange rate (LCU per US$ period average) of Papua New Guinea in 2003 to that in 2009?
Make the answer very short. 1.29. What is the ratio of the Official exchange rate (LCU per US$ period average) of Kazakhstan in 2004 to that in 2005?
Provide a succinct answer. 1.02. What is the ratio of the Official exchange rate (LCU per US$ period average) of Libya in 2004 to that in 2005?
Make the answer very short. 1. What is the ratio of the Official exchange rate (LCU per US$ period average) of Papua New Guinea in 2004 to that in 2005?
Your answer should be compact. 1.04. What is the ratio of the Official exchange rate (LCU per US$ period average) in Kazakhstan in 2004 to that in 2006?
Provide a succinct answer. 1.08. What is the ratio of the Official exchange rate (LCU per US$ period average) in Papua New Guinea in 2004 to that in 2006?
Provide a succinct answer. 1.05. What is the ratio of the Official exchange rate (LCU per US$ period average) in Kazakhstan in 2004 to that in 2007?
Your answer should be compact. 1.11. What is the ratio of the Official exchange rate (LCU per US$ period average) in Libya in 2004 to that in 2007?
Ensure brevity in your answer.  1.03. What is the ratio of the Official exchange rate (LCU per US$ period average) in Papua New Guinea in 2004 to that in 2007?
Give a very brief answer. 1.09. What is the ratio of the Official exchange rate (LCU per US$ period average) of Kazakhstan in 2004 to that in 2008?
Provide a succinct answer. 1.13. What is the ratio of the Official exchange rate (LCU per US$ period average) of Libya in 2004 to that in 2008?
Your answer should be compact. 1.07. What is the ratio of the Official exchange rate (LCU per US$ period average) of Papua New Guinea in 2004 to that in 2008?
Your response must be concise. 1.19. What is the ratio of the Official exchange rate (LCU per US$ period average) in Kazakhstan in 2004 to that in 2009?
Offer a very short reply. 0.92. What is the ratio of the Official exchange rate (LCU per US$ period average) in Libya in 2004 to that in 2009?
Make the answer very short. 1.04. What is the ratio of the Official exchange rate (LCU per US$ period average) in Papua New Guinea in 2004 to that in 2009?
Keep it short and to the point. 1.17. What is the ratio of the Official exchange rate (LCU per US$ period average) of Kazakhstan in 2005 to that in 2006?
Offer a terse response. 1.05. What is the ratio of the Official exchange rate (LCU per US$ period average) of Libya in 2005 to that in 2006?
Your answer should be compact. 1. What is the ratio of the Official exchange rate (LCU per US$ period average) of Papua New Guinea in 2005 to that in 2006?
Offer a very short reply. 1.01. What is the ratio of the Official exchange rate (LCU per US$ period average) of Kazakhstan in 2005 to that in 2007?
Give a very brief answer. 1.08. What is the ratio of the Official exchange rate (LCU per US$ period average) of Libya in 2005 to that in 2007?
Provide a short and direct response. 1.04. What is the ratio of the Official exchange rate (LCU per US$ period average) of Papua New Guinea in 2005 to that in 2007?
Offer a very short reply. 1.05. What is the ratio of the Official exchange rate (LCU per US$ period average) in Kazakhstan in 2005 to that in 2008?
Provide a succinct answer. 1.1. What is the ratio of the Official exchange rate (LCU per US$ period average) in Libya in 2005 to that in 2008?
Make the answer very short. 1.07. What is the ratio of the Official exchange rate (LCU per US$ period average) of Papua New Guinea in 2005 to that in 2008?
Ensure brevity in your answer.  1.15. What is the ratio of the Official exchange rate (LCU per US$ period average) of Kazakhstan in 2005 to that in 2009?
Offer a very short reply. 0.9. What is the ratio of the Official exchange rate (LCU per US$ period average) in Libya in 2005 to that in 2009?
Give a very brief answer. 1.04. What is the ratio of the Official exchange rate (LCU per US$ period average) of Papua New Guinea in 2005 to that in 2009?
Your answer should be compact. 1.13. What is the ratio of the Official exchange rate (LCU per US$ period average) of Kazakhstan in 2006 to that in 2007?
Keep it short and to the point. 1.03. What is the ratio of the Official exchange rate (LCU per US$ period average) in Libya in 2006 to that in 2007?
Your answer should be very brief. 1.04. What is the ratio of the Official exchange rate (LCU per US$ period average) in Papua New Guinea in 2006 to that in 2007?
Your answer should be very brief. 1.03. What is the ratio of the Official exchange rate (LCU per US$ period average) in Kazakhstan in 2006 to that in 2008?
Provide a succinct answer. 1.05. What is the ratio of the Official exchange rate (LCU per US$ period average) of Libya in 2006 to that in 2008?
Offer a very short reply. 1.07. What is the ratio of the Official exchange rate (LCU per US$ period average) in Papua New Guinea in 2006 to that in 2008?
Your response must be concise. 1.13. What is the ratio of the Official exchange rate (LCU per US$ period average) in Kazakhstan in 2006 to that in 2009?
Keep it short and to the point. 0.85. What is the ratio of the Official exchange rate (LCU per US$ period average) in Libya in 2006 to that in 2009?
Ensure brevity in your answer.  1.05. What is the ratio of the Official exchange rate (LCU per US$ period average) in Papua New Guinea in 2006 to that in 2009?
Make the answer very short. 1.11. What is the ratio of the Official exchange rate (LCU per US$ period average) of Kazakhstan in 2007 to that in 2008?
Offer a terse response. 1.02. What is the ratio of the Official exchange rate (LCU per US$ period average) of Libya in 2007 to that in 2008?
Your answer should be compact. 1.03. What is the ratio of the Official exchange rate (LCU per US$ period average) in Papua New Guinea in 2007 to that in 2008?
Keep it short and to the point. 1.1. What is the ratio of the Official exchange rate (LCU per US$ period average) of Kazakhstan in 2007 to that in 2009?
Provide a succinct answer. 0.83. What is the ratio of the Official exchange rate (LCU per US$ period average) in Libya in 2007 to that in 2009?
Your answer should be compact. 1.01. What is the ratio of the Official exchange rate (LCU per US$ period average) of Papua New Guinea in 2007 to that in 2009?
Offer a very short reply. 1.08. What is the ratio of the Official exchange rate (LCU per US$ period average) in Kazakhstan in 2008 to that in 2009?
Your answer should be compact. 0.82. What is the ratio of the Official exchange rate (LCU per US$ period average) in Libya in 2008 to that in 2009?
Keep it short and to the point. 0.98. What is the ratio of the Official exchange rate (LCU per US$ period average) in Papua New Guinea in 2008 to that in 2009?
Offer a terse response. 0.98. What is the difference between the highest and the second highest Official exchange rate (LCU per US$ period average) of Kazakhstan?
Give a very brief answer. 3.7. What is the difference between the highest and the second highest Official exchange rate (LCU per US$ period average) of Libya?
Your answer should be very brief. 0.01. What is the difference between the highest and the second highest Official exchange rate (LCU per US$ period average) of Papua New Guinea?
Your answer should be compact. 0.33. What is the difference between the highest and the lowest Official exchange rate (LCU per US$ period average) in Kazakhstan?
Ensure brevity in your answer.  32.98. What is the difference between the highest and the lowest Official exchange rate (LCU per US$ period average) of Libya?
Give a very brief answer. 0.09. What is the difference between the highest and the lowest Official exchange rate (LCU per US$ period average) in Papua New Guinea?
Offer a terse response. 1.2. 